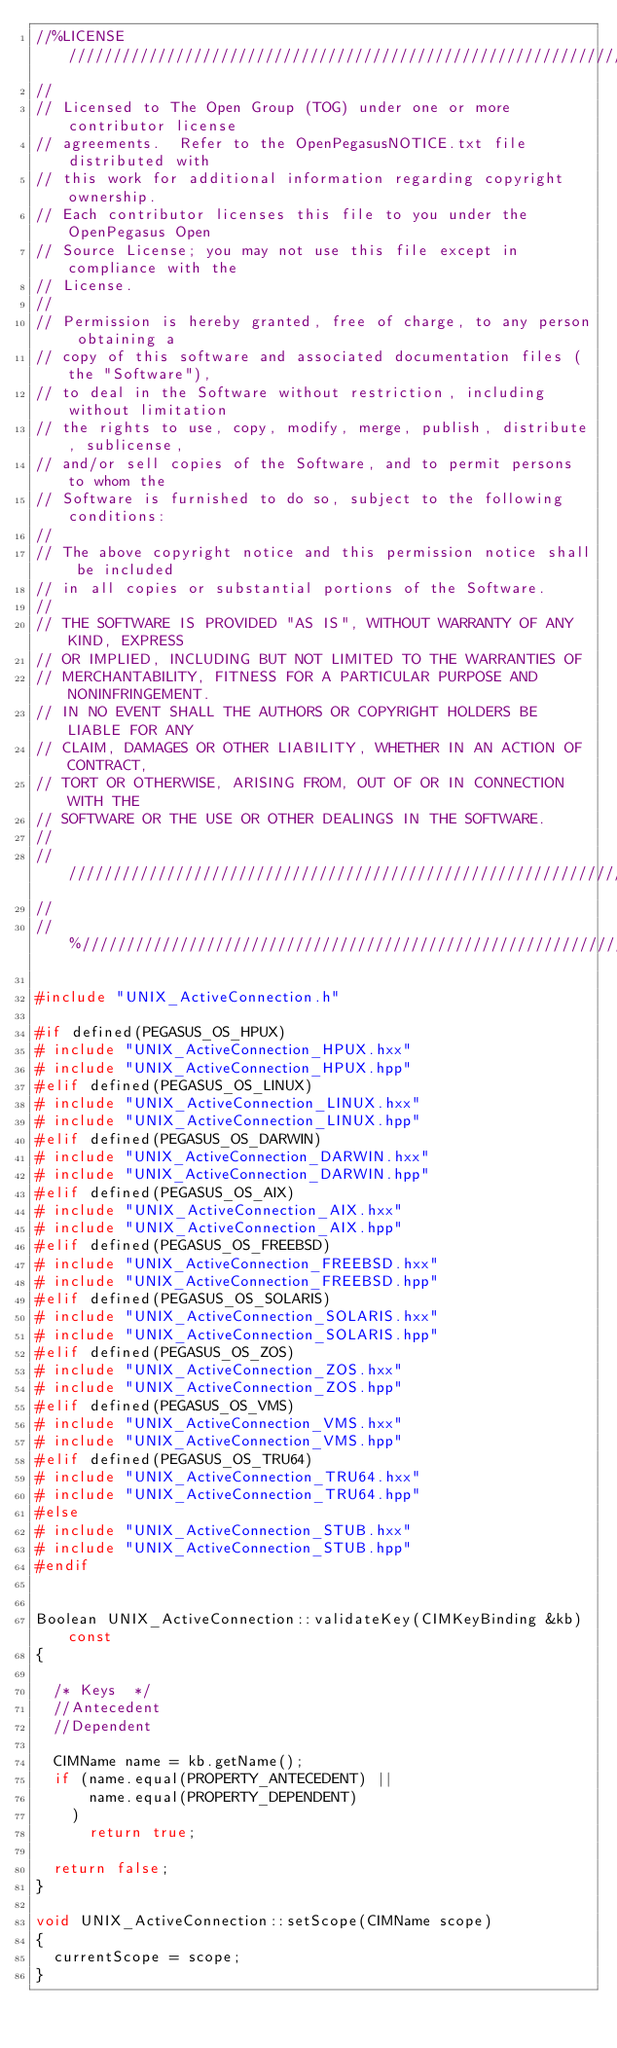<code> <loc_0><loc_0><loc_500><loc_500><_C++_>//%LICENSE////////////////////////////////////////////////////////////////
//
// Licensed to The Open Group (TOG) under one or more contributor license
// agreements.  Refer to the OpenPegasusNOTICE.txt file distributed with
// this work for additional information regarding copyright ownership.
// Each contributor licenses this file to you under the OpenPegasus Open
// Source License; you may not use this file except in compliance with the
// License.
//
// Permission is hereby granted, free of charge, to any person obtaining a
// copy of this software and associated documentation files (the "Software"),
// to deal in the Software without restriction, including without limitation
// the rights to use, copy, modify, merge, publish, distribute, sublicense,
// and/or sell copies of the Software, and to permit persons to whom the
// Software is furnished to do so, subject to the following conditions:
//
// The above copyright notice and this permission notice shall be included
// in all copies or substantial portions of the Software.
//
// THE SOFTWARE IS PROVIDED "AS IS", WITHOUT WARRANTY OF ANY KIND, EXPRESS
// OR IMPLIED, INCLUDING BUT NOT LIMITED TO THE WARRANTIES OF
// MERCHANTABILITY, FITNESS FOR A PARTICULAR PURPOSE AND NONINFRINGEMENT.
// IN NO EVENT SHALL THE AUTHORS OR COPYRIGHT HOLDERS BE LIABLE FOR ANY
// CLAIM, DAMAGES OR OTHER LIABILITY, WHETHER IN AN ACTION OF CONTRACT,
// TORT OR OTHERWISE, ARISING FROM, OUT OF OR IN CONNECTION WITH THE
// SOFTWARE OR THE USE OR OTHER DEALINGS IN THE SOFTWARE.
//
//////////////////////////////////////////////////////////////////////////
//
//%/////////////////////////////////////////////////////////////////////////

#include "UNIX_ActiveConnection.h"

#if defined(PEGASUS_OS_HPUX)
#	include "UNIX_ActiveConnection_HPUX.hxx"
#	include "UNIX_ActiveConnection_HPUX.hpp"
#elif defined(PEGASUS_OS_LINUX)
#	include "UNIX_ActiveConnection_LINUX.hxx"
#	include "UNIX_ActiveConnection_LINUX.hpp"
#elif defined(PEGASUS_OS_DARWIN)
#	include "UNIX_ActiveConnection_DARWIN.hxx"
#	include "UNIX_ActiveConnection_DARWIN.hpp"
#elif defined(PEGASUS_OS_AIX)
#	include "UNIX_ActiveConnection_AIX.hxx"
#	include "UNIX_ActiveConnection_AIX.hpp"
#elif defined(PEGASUS_OS_FREEBSD)
#	include "UNIX_ActiveConnection_FREEBSD.hxx"
#	include "UNIX_ActiveConnection_FREEBSD.hpp"
#elif defined(PEGASUS_OS_SOLARIS)
#	include "UNIX_ActiveConnection_SOLARIS.hxx"
#	include "UNIX_ActiveConnection_SOLARIS.hpp"
#elif defined(PEGASUS_OS_ZOS)
#	include "UNIX_ActiveConnection_ZOS.hxx"
#	include "UNIX_ActiveConnection_ZOS.hpp"
#elif defined(PEGASUS_OS_VMS)
#	include "UNIX_ActiveConnection_VMS.hxx"
#	include "UNIX_ActiveConnection_VMS.hpp"
#elif defined(PEGASUS_OS_TRU64)
#	include "UNIX_ActiveConnection_TRU64.hxx"
#	include "UNIX_ActiveConnection_TRU64.hpp"
#else
#	include "UNIX_ActiveConnection_STUB.hxx"
#	include "UNIX_ActiveConnection_STUB.hpp"
#endif


Boolean UNIX_ActiveConnection::validateKey(CIMKeyBinding &kb) const
{

	/* Keys  */
	//Antecedent
	//Dependent

	CIMName name = kb.getName();
	if (name.equal(PROPERTY_ANTECEDENT) ||
			name.equal(PROPERTY_DEPENDENT)
		)
			return true;

	return false;
}

void UNIX_ActiveConnection::setScope(CIMName scope)
{
	currentScope = scope;
}

</code> 